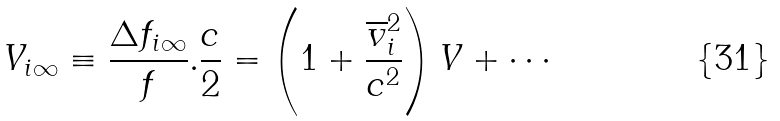<formula> <loc_0><loc_0><loc_500><loc_500>V _ { i \infty } \equiv \frac { \Delta f _ { i \infty } } { f } . \frac { c } { 2 } = \left ( 1 + \frac { \overline { v } _ { i } ^ { 2 } } { c ^ { 2 } } \right ) V + \cdots</formula> 